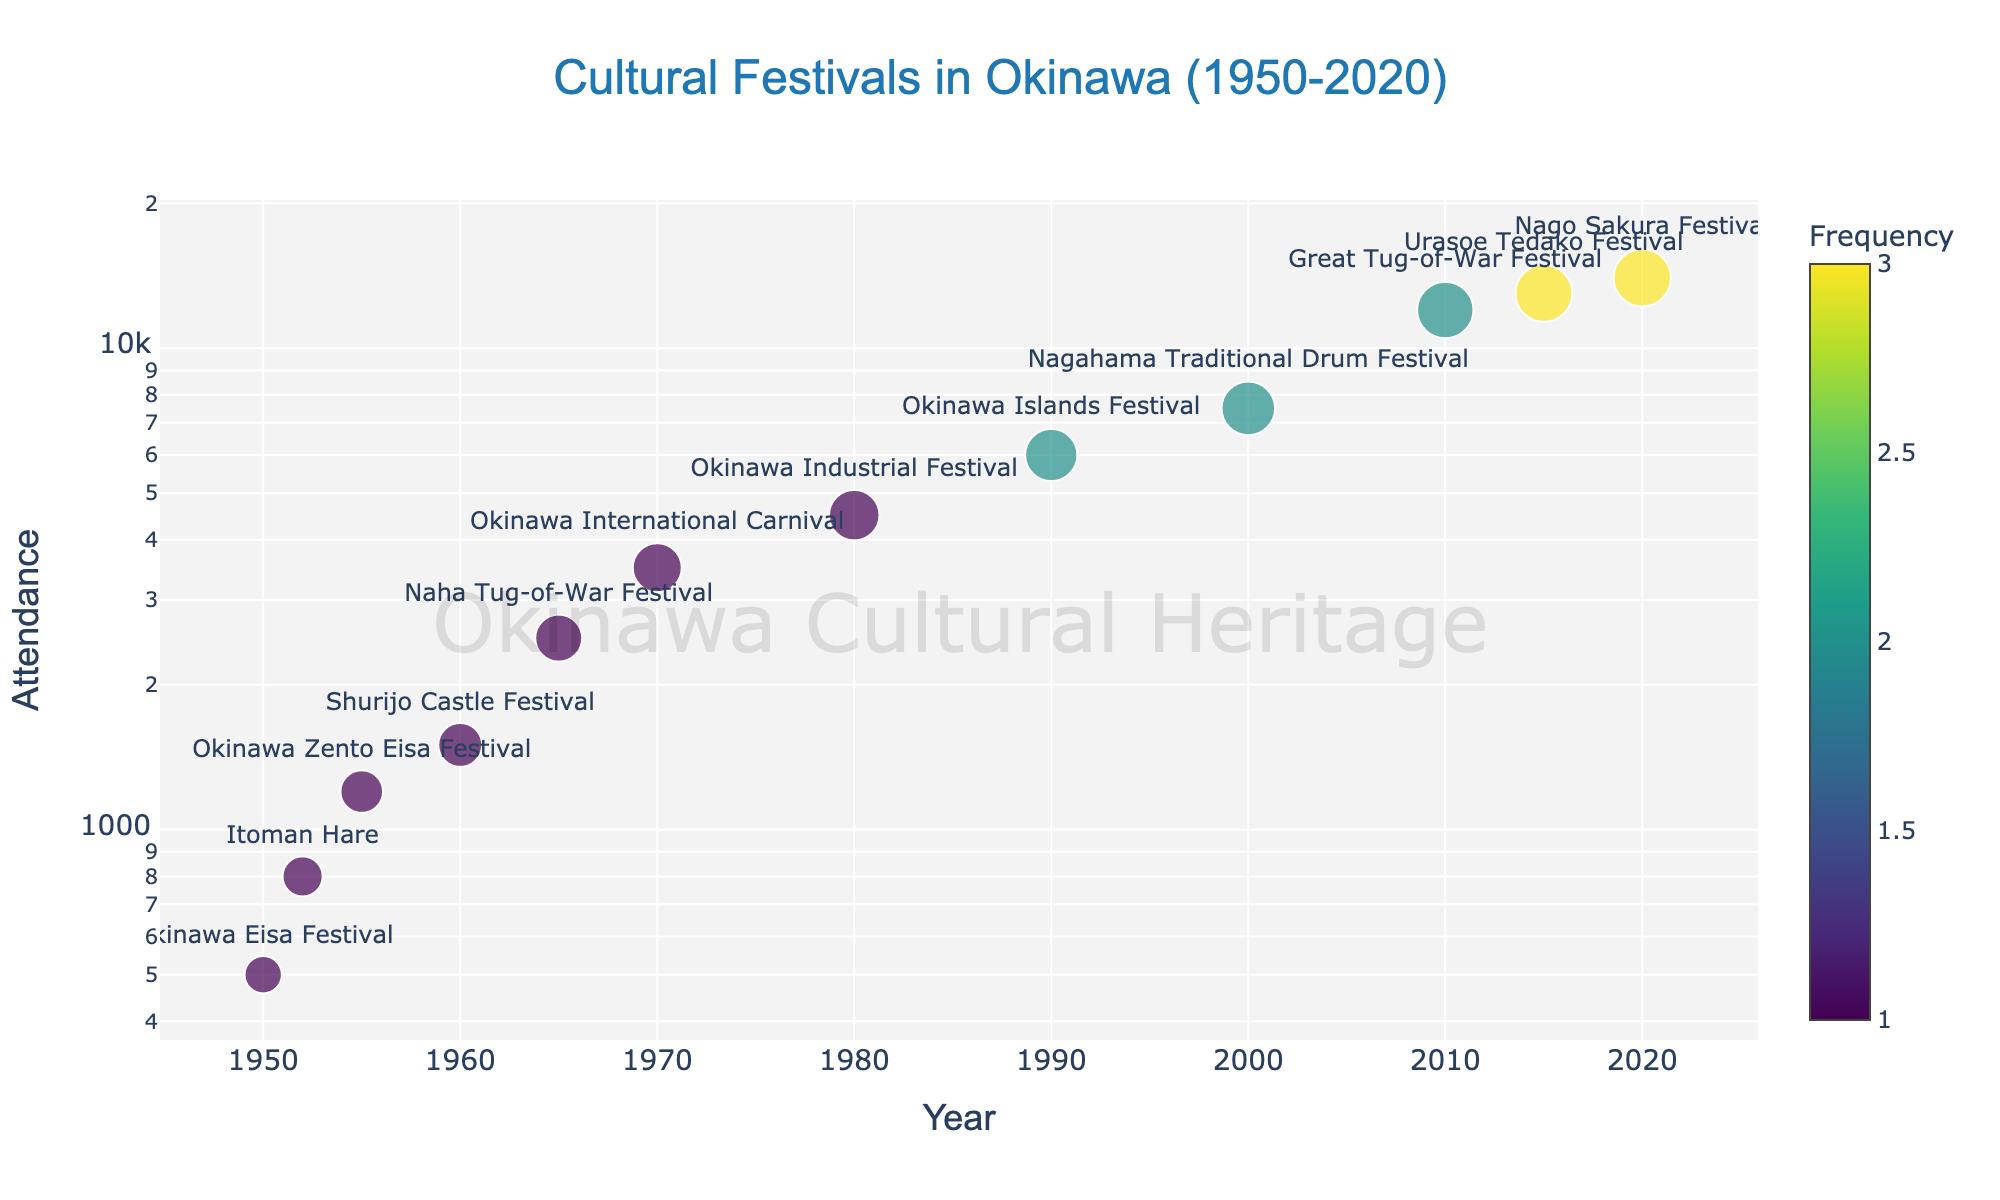What is the title of the figure? The title is found at the top center of the figure. It provides a concise description of the data being displayed.
Answer: Cultural Festivals in Okinawa (1950-2020) How many data points are shown in the figure? Each data point represents a festival held in Okinawa with its respective year and attendance. By counting these points, we can determine the total number of data points.
Answer: 12 Which festival had the highest attendance and in what year did it occur? By observing the y-axis (log scale for attendance) and the marker closest to the top, we can identify the festival with the highest attendance and its corresponding year.
Answer: Nago Sakura Festival, 2020 What is the range of years covered in the figure? The x-axis shows the timeline from the earliest to the latest year, indicating the range of years covered.
Answer: 1950 to 2020 Which festival occurs most frequently and what is its attendance? The color of the markers indicates frequency, with darker colors representing higher frequencies. Identify the festival with the darkest color and check its associated attendance.
Answer: Urasoe Tedako Festival, 13000 What is the average attendance of the festivals held more than once? First, identify festivals with a frequency greater than 1 by their color and calculate the average of their attendances.
Answer: (6000 + 7500 + 12000 + 13000 + 14000) / 5 ≈ 10500 Which festival had a steep increase in attendance compared to the festival held just before it? By observing the y-axis and the relative positions of the markers, we can identify the festival where the attendance value markedly increased compared to the previous festival.
Answer: Great Tug-of-War Festival (2010) compared to Nagahama Traditional Drum Festival (2000) Between 1950 and 1980, which festival had the highest attendance? Focus on the data points from 1950 to 1980 and identify the one with the highest position along the y-axis.
Answer: Okinawa Industrial Festival, 4500 What is the trend in attendance numbers from the 1950s to today? By looking at the position of data points from left to right (1950s to 2020), observe the overall pattern of attendance numbers.
Answer: Increasing trend How does the attendance of the Naha Tug-of-War Festival compare to the Okinawa Eisa Festival? Locate both festivals on the plot and compare their positions along the y-axis to determine the relative difference in attendance.
Answer: Naha Tug-of-War Festival's attendance (2500) is higher than Okinawa Eisa Festival's (500) 